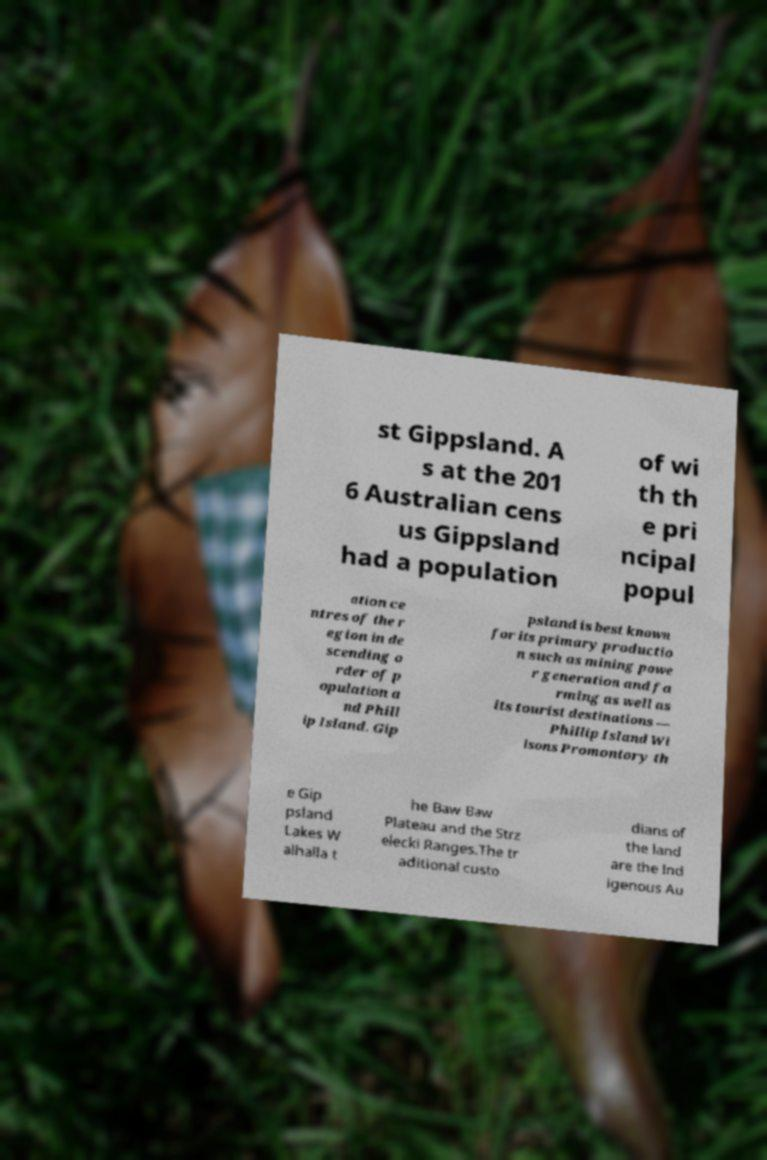For documentation purposes, I need the text within this image transcribed. Could you provide that? st Gippsland. A s at the 201 6 Australian cens us Gippsland had a population of wi th th e pri ncipal popul ation ce ntres of the r egion in de scending o rder of p opulation a nd Phill ip Island. Gip psland is best known for its primary productio n such as mining powe r generation and fa rming as well as its tourist destinations — Phillip Island Wi lsons Promontory th e Gip psland Lakes W alhalla t he Baw Baw Plateau and the Strz elecki Ranges.The tr aditional custo dians of the land are the Ind igenous Au 